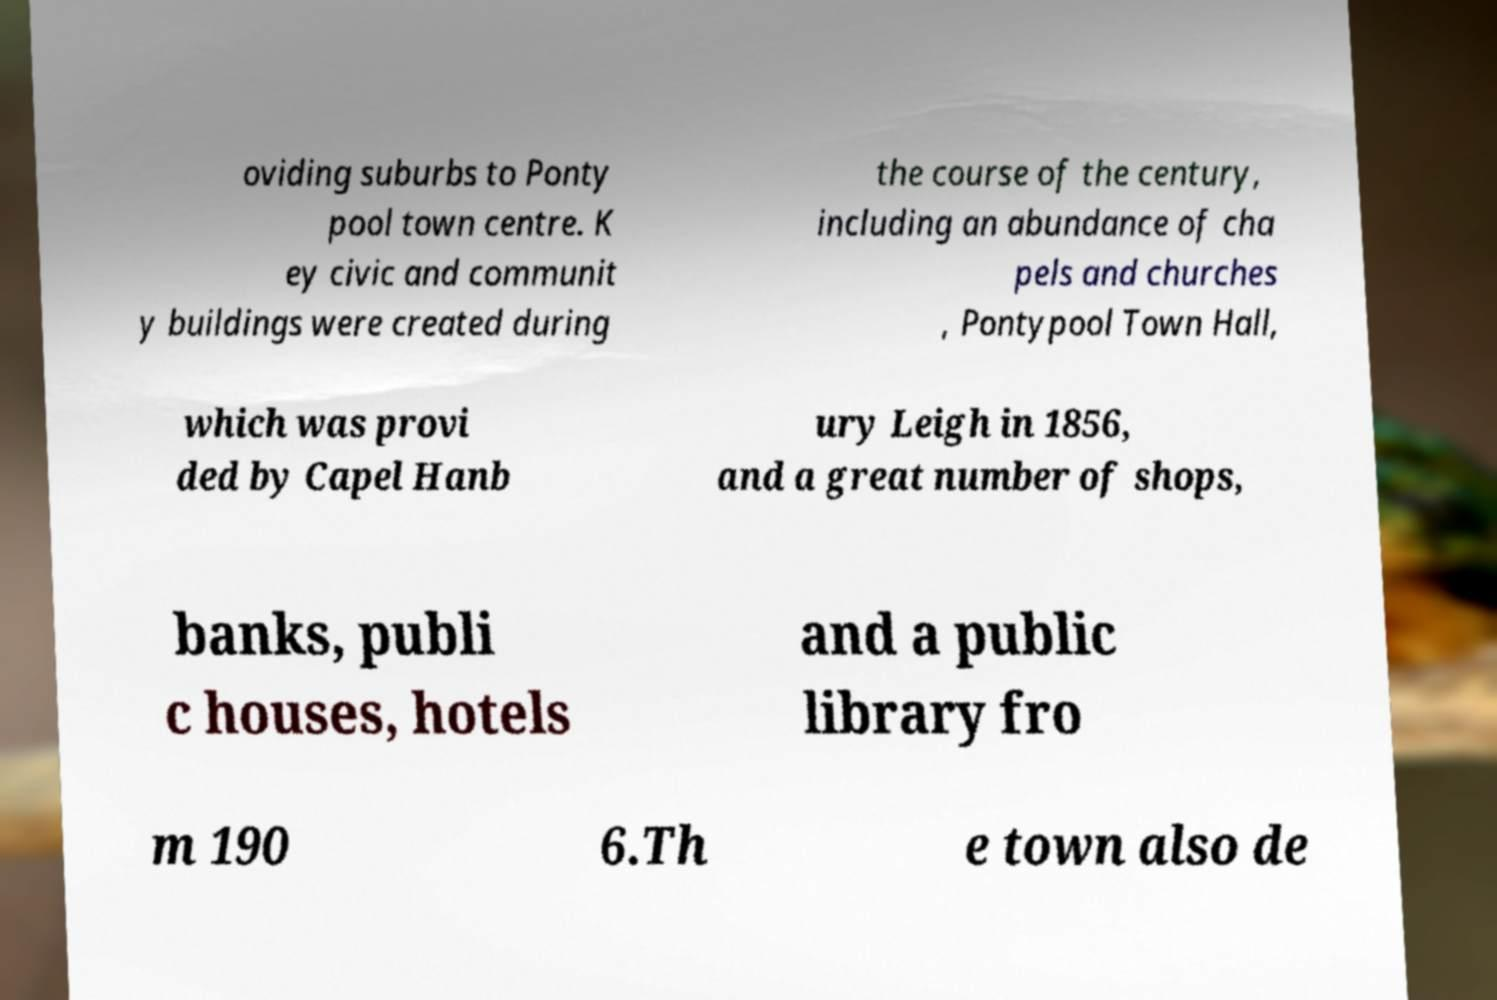Can you accurately transcribe the text from the provided image for me? oviding suburbs to Ponty pool town centre. K ey civic and communit y buildings were created during the course of the century, including an abundance of cha pels and churches , Pontypool Town Hall, which was provi ded by Capel Hanb ury Leigh in 1856, and a great number of shops, banks, publi c houses, hotels and a public library fro m 190 6.Th e town also de 